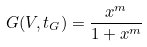Convert formula to latex. <formula><loc_0><loc_0><loc_500><loc_500>G ( V , t _ { G } ) = \frac { x ^ { m } } { 1 + x ^ { m } }</formula> 